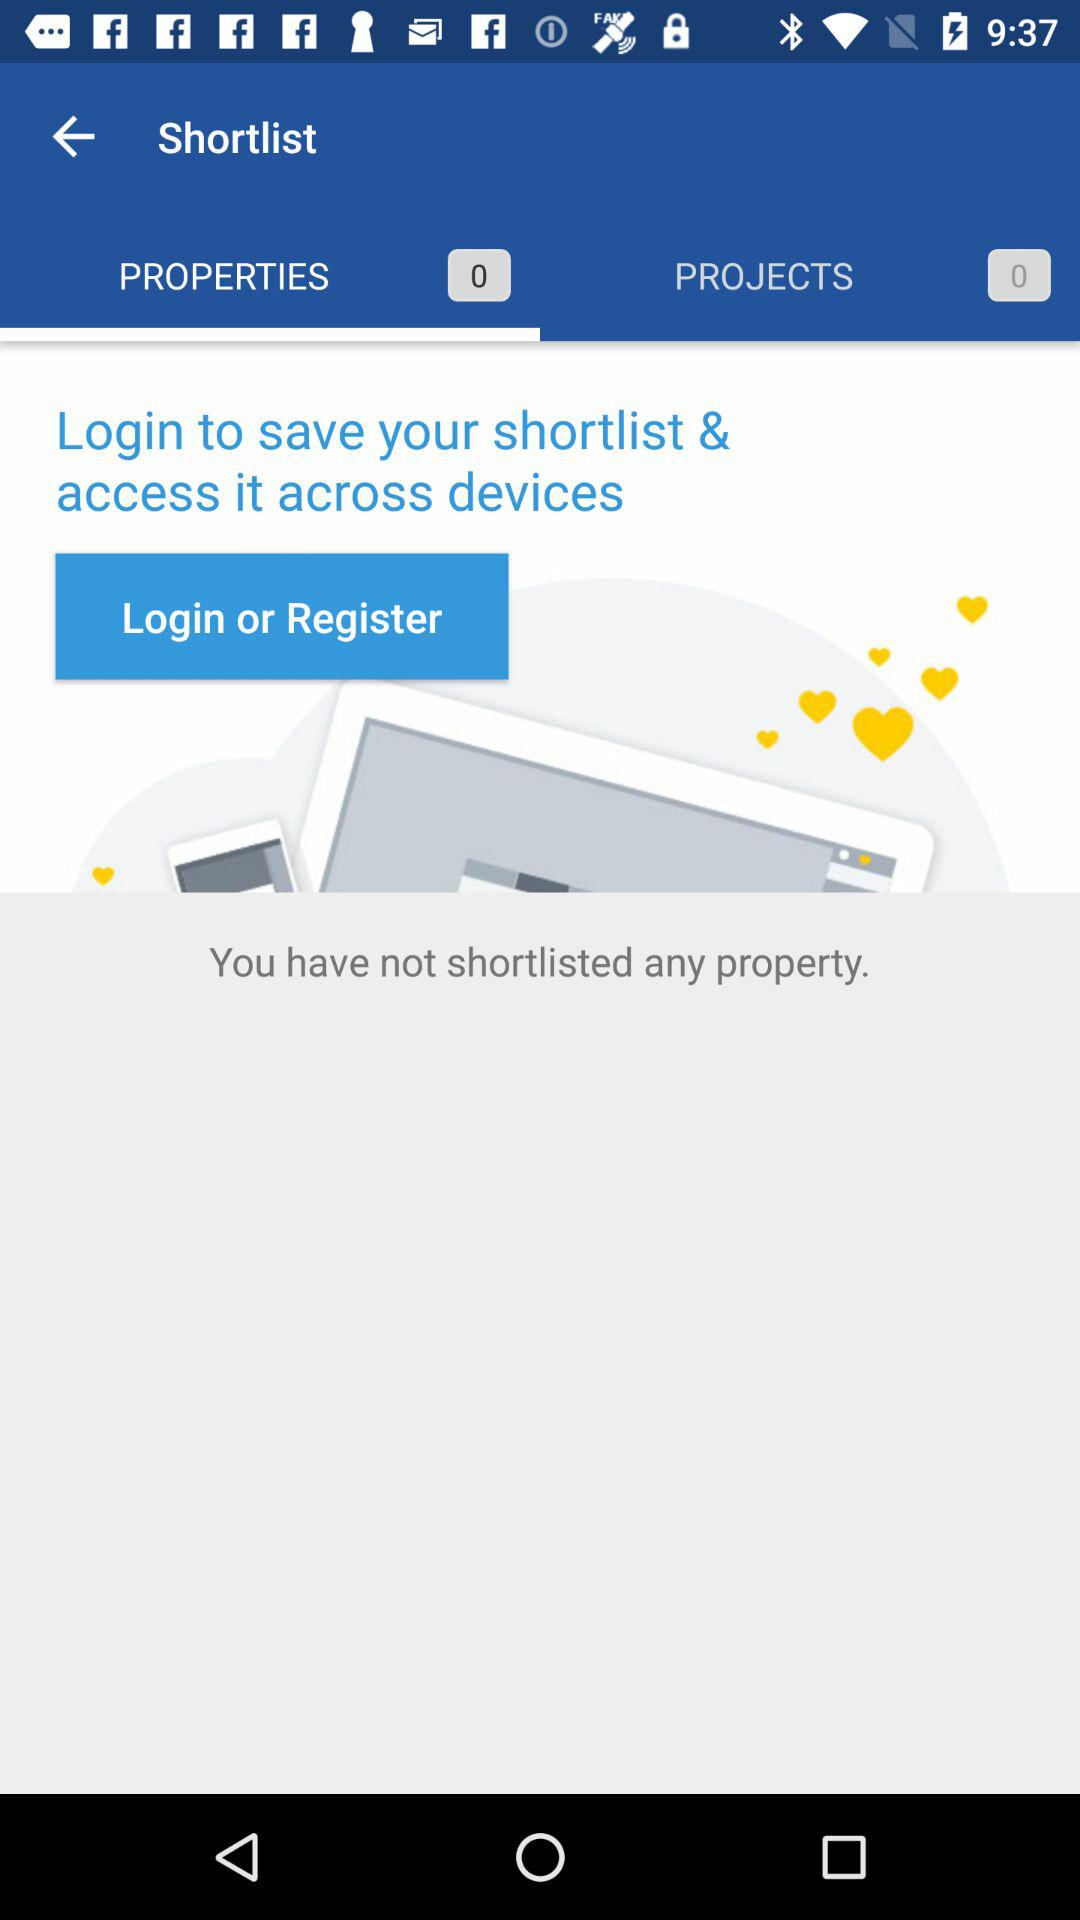What is the selected tab? The selected tab is "PROPERTIES 0". 